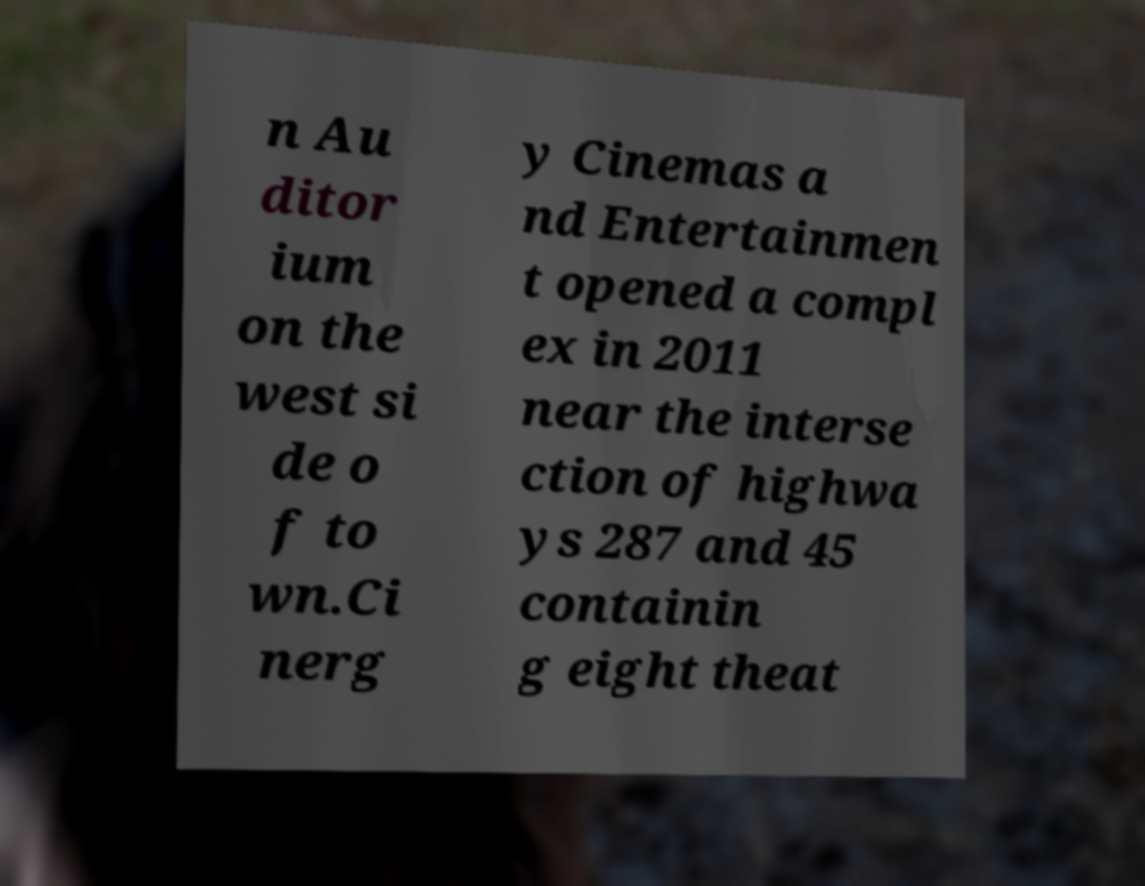Please identify and transcribe the text found in this image. n Au ditor ium on the west si de o f to wn.Ci nerg y Cinemas a nd Entertainmen t opened a compl ex in 2011 near the interse ction of highwa ys 287 and 45 containin g eight theat 